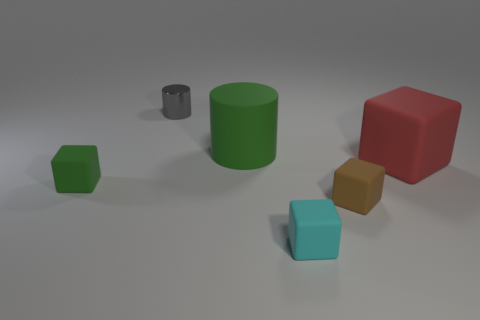Add 4 small cylinders. How many objects exist? 10 Subtract all cylinders. How many objects are left? 4 Add 4 big gray matte things. How many big gray matte things exist? 4 Subtract 0 purple cubes. How many objects are left? 6 Subtract all green shiny blocks. Subtract all metallic cylinders. How many objects are left? 5 Add 3 red rubber cubes. How many red rubber cubes are left? 4 